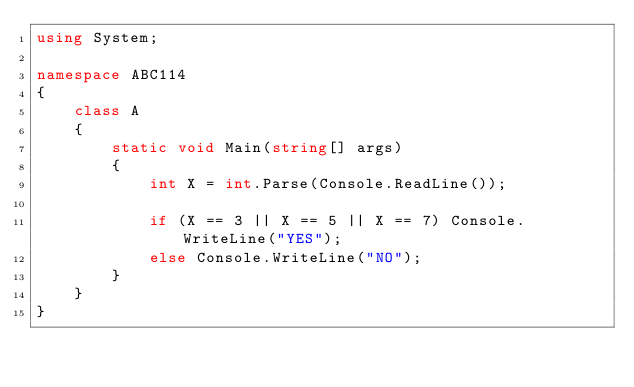Convert code to text. <code><loc_0><loc_0><loc_500><loc_500><_C#_>using System;

namespace ABC114
{
    class A
    {
        static void Main(string[] args)
        {
            int X = int.Parse(Console.ReadLine());

            if (X == 3 || X == 5 || X == 7) Console.WriteLine("YES");
            else Console.WriteLine("NO");
        }
    }
}
</code> 